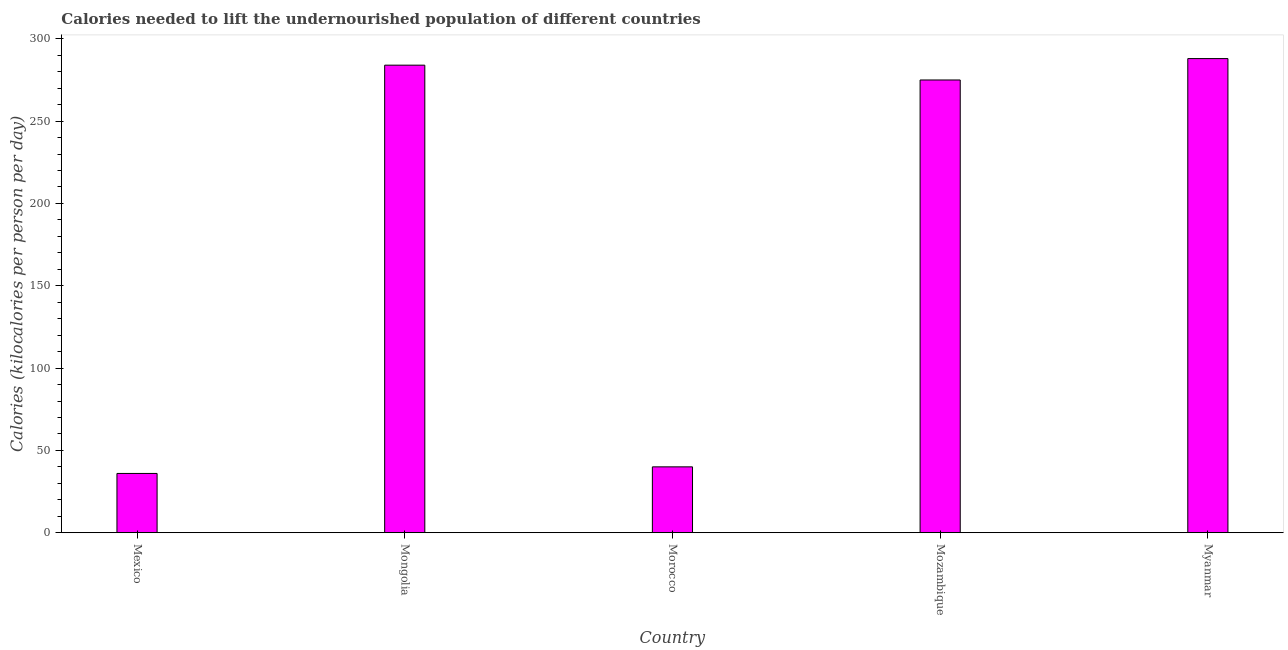Does the graph contain any zero values?
Make the answer very short. No. Does the graph contain grids?
Keep it short and to the point. No. What is the title of the graph?
Ensure brevity in your answer.  Calories needed to lift the undernourished population of different countries. What is the label or title of the Y-axis?
Ensure brevity in your answer.  Calories (kilocalories per person per day). What is the depth of food deficit in Mongolia?
Offer a very short reply. 284. Across all countries, what is the maximum depth of food deficit?
Keep it short and to the point. 288. Across all countries, what is the minimum depth of food deficit?
Give a very brief answer. 36. In which country was the depth of food deficit maximum?
Provide a succinct answer. Myanmar. In which country was the depth of food deficit minimum?
Ensure brevity in your answer.  Mexico. What is the sum of the depth of food deficit?
Ensure brevity in your answer.  923. What is the difference between the depth of food deficit in Morocco and Myanmar?
Keep it short and to the point. -248. What is the average depth of food deficit per country?
Keep it short and to the point. 184.6. What is the median depth of food deficit?
Ensure brevity in your answer.  275. What is the ratio of the depth of food deficit in Mozambique to that in Myanmar?
Give a very brief answer. 0.95. What is the difference between the highest and the second highest depth of food deficit?
Give a very brief answer. 4. Is the sum of the depth of food deficit in Mozambique and Myanmar greater than the maximum depth of food deficit across all countries?
Ensure brevity in your answer.  Yes. What is the difference between the highest and the lowest depth of food deficit?
Make the answer very short. 252. How many bars are there?
Your response must be concise. 5. Are the values on the major ticks of Y-axis written in scientific E-notation?
Make the answer very short. No. What is the Calories (kilocalories per person per day) in Mexico?
Offer a terse response. 36. What is the Calories (kilocalories per person per day) of Mongolia?
Offer a terse response. 284. What is the Calories (kilocalories per person per day) in Morocco?
Your response must be concise. 40. What is the Calories (kilocalories per person per day) of Mozambique?
Your answer should be compact. 275. What is the Calories (kilocalories per person per day) in Myanmar?
Provide a short and direct response. 288. What is the difference between the Calories (kilocalories per person per day) in Mexico and Mongolia?
Offer a very short reply. -248. What is the difference between the Calories (kilocalories per person per day) in Mexico and Mozambique?
Provide a short and direct response. -239. What is the difference between the Calories (kilocalories per person per day) in Mexico and Myanmar?
Give a very brief answer. -252. What is the difference between the Calories (kilocalories per person per day) in Mongolia and Morocco?
Ensure brevity in your answer.  244. What is the difference between the Calories (kilocalories per person per day) in Mongolia and Myanmar?
Your answer should be very brief. -4. What is the difference between the Calories (kilocalories per person per day) in Morocco and Mozambique?
Offer a terse response. -235. What is the difference between the Calories (kilocalories per person per day) in Morocco and Myanmar?
Your response must be concise. -248. What is the ratio of the Calories (kilocalories per person per day) in Mexico to that in Mongolia?
Offer a terse response. 0.13. What is the ratio of the Calories (kilocalories per person per day) in Mexico to that in Morocco?
Make the answer very short. 0.9. What is the ratio of the Calories (kilocalories per person per day) in Mexico to that in Mozambique?
Provide a succinct answer. 0.13. What is the ratio of the Calories (kilocalories per person per day) in Mongolia to that in Morocco?
Your answer should be very brief. 7.1. What is the ratio of the Calories (kilocalories per person per day) in Mongolia to that in Mozambique?
Provide a short and direct response. 1.03. What is the ratio of the Calories (kilocalories per person per day) in Morocco to that in Mozambique?
Offer a terse response. 0.14. What is the ratio of the Calories (kilocalories per person per day) in Morocco to that in Myanmar?
Give a very brief answer. 0.14. What is the ratio of the Calories (kilocalories per person per day) in Mozambique to that in Myanmar?
Make the answer very short. 0.95. 